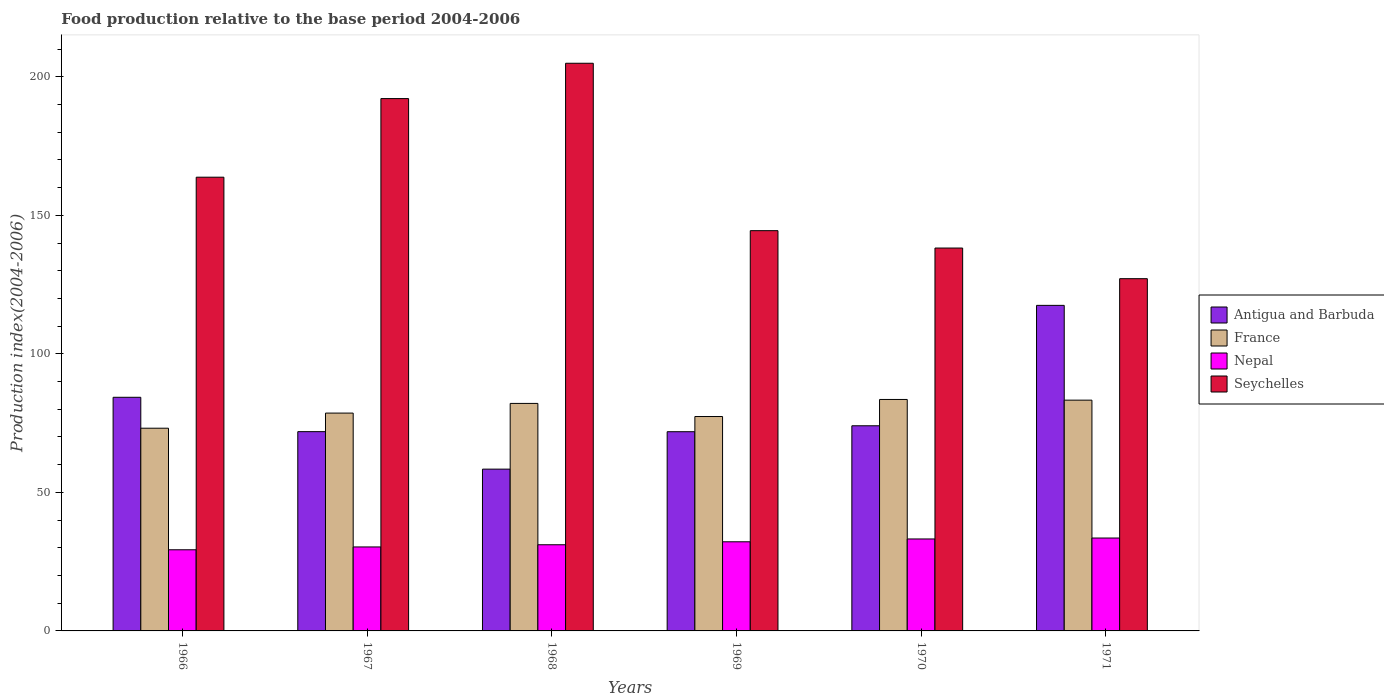How many bars are there on the 4th tick from the left?
Your response must be concise. 4. What is the label of the 5th group of bars from the left?
Your response must be concise. 1970. What is the food production index in France in 1969?
Keep it short and to the point. 77.38. Across all years, what is the maximum food production index in France?
Offer a terse response. 83.54. Across all years, what is the minimum food production index in Antigua and Barbuda?
Provide a short and direct response. 58.39. In which year was the food production index in France minimum?
Provide a short and direct response. 1966. What is the total food production index in France in the graph?
Your answer should be compact. 478.1. What is the difference between the food production index in Seychelles in 1966 and that in 1967?
Provide a succinct answer. -28.37. What is the difference between the food production index in Seychelles in 1971 and the food production index in France in 1967?
Your answer should be compact. 48.51. What is the average food production index in Seychelles per year?
Offer a terse response. 161.76. In the year 1966, what is the difference between the food production index in Nepal and food production index in Antigua and Barbuda?
Ensure brevity in your answer.  -55.03. In how many years, is the food production index in Seychelles greater than 110?
Keep it short and to the point. 6. What is the ratio of the food production index in Antigua and Barbuda in 1970 to that in 1971?
Your answer should be compact. 0.63. What is the difference between the highest and the second highest food production index in Seychelles?
Provide a short and direct response. 12.75. What is the difference between the highest and the lowest food production index in Seychelles?
Provide a succinct answer. 77.75. In how many years, is the food production index in Seychelles greater than the average food production index in Seychelles taken over all years?
Your response must be concise. 3. What does the 3rd bar from the left in 1969 represents?
Make the answer very short. Nepal. What does the 2nd bar from the right in 1969 represents?
Make the answer very short. Nepal. How many bars are there?
Provide a succinct answer. 24. How many years are there in the graph?
Your answer should be very brief. 6. Are the values on the major ticks of Y-axis written in scientific E-notation?
Provide a short and direct response. No. Does the graph contain any zero values?
Offer a very short reply. No. How are the legend labels stacked?
Your answer should be very brief. Vertical. What is the title of the graph?
Offer a terse response. Food production relative to the base period 2004-2006. Does "Lao PDR" appear as one of the legend labels in the graph?
Keep it short and to the point. No. What is the label or title of the Y-axis?
Give a very brief answer. Production index(2004-2006). What is the Production index(2004-2006) of Antigua and Barbuda in 1966?
Make the answer very short. 84.32. What is the Production index(2004-2006) of France in 1966?
Your answer should be compact. 73.16. What is the Production index(2004-2006) of Nepal in 1966?
Your answer should be compact. 29.29. What is the Production index(2004-2006) in Seychelles in 1966?
Make the answer very short. 163.76. What is the Production index(2004-2006) of Antigua and Barbuda in 1967?
Make the answer very short. 71.92. What is the Production index(2004-2006) of France in 1967?
Give a very brief answer. 78.62. What is the Production index(2004-2006) of Nepal in 1967?
Your answer should be very brief. 30.31. What is the Production index(2004-2006) of Seychelles in 1967?
Keep it short and to the point. 192.13. What is the Production index(2004-2006) in Antigua and Barbuda in 1968?
Keep it short and to the point. 58.39. What is the Production index(2004-2006) of France in 1968?
Offer a terse response. 82.11. What is the Production index(2004-2006) of Nepal in 1968?
Make the answer very short. 31.1. What is the Production index(2004-2006) of Seychelles in 1968?
Give a very brief answer. 204.88. What is the Production index(2004-2006) in Antigua and Barbuda in 1969?
Offer a very short reply. 71.9. What is the Production index(2004-2006) in France in 1969?
Provide a short and direct response. 77.38. What is the Production index(2004-2006) of Nepal in 1969?
Your answer should be compact. 32.17. What is the Production index(2004-2006) in Seychelles in 1969?
Ensure brevity in your answer.  144.46. What is the Production index(2004-2006) in Antigua and Barbuda in 1970?
Make the answer very short. 74.04. What is the Production index(2004-2006) of France in 1970?
Offer a very short reply. 83.54. What is the Production index(2004-2006) of Nepal in 1970?
Provide a short and direct response. 33.19. What is the Production index(2004-2006) of Seychelles in 1970?
Your answer should be compact. 138.19. What is the Production index(2004-2006) of Antigua and Barbuda in 1971?
Give a very brief answer. 117.5. What is the Production index(2004-2006) in France in 1971?
Give a very brief answer. 83.29. What is the Production index(2004-2006) of Nepal in 1971?
Ensure brevity in your answer.  33.53. What is the Production index(2004-2006) of Seychelles in 1971?
Offer a very short reply. 127.13. Across all years, what is the maximum Production index(2004-2006) in Antigua and Barbuda?
Make the answer very short. 117.5. Across all years, what is the maximum Production index(2004-2006) in France?
Your answer should be compact. 83.54. Across all years, what is the maximum Production index(2004-2006) of Nepal?
Your response must be concise. 33.53. Across all years, what is the maximum Production index(2004-2006) in Seychelles?
Ensure brevity in your answer.  204.88. Across all years, what is the minimum Production index(2004-2006) in Antigua and Barbuda?
Your answer should be very brief. 58.39. Across all years, what is the minimum Production index(2004-2006) of France?
Your response must be concise. 73.16. Across all years, what is the minimum Production index(2004-2006) in Nepal?
Offer a terse response. 29.29. Across all years, what is the minimum Production index(2004-2006) of Seychelles?
Make the answer very short. 127.13. What is the total Production index(2004-2006) of Antigua and Barbuda in the graph?
Make the answer very short. 478.07. What is the total Production index(2004-2006) of France in the graph?
Your answer should be compact. 478.1. What is the total Production index(2004-2006) of Nepal in the graph?
Provide a succinct answer. 189.59. What is the total Production index(2004-2006) of Seychelles in the graph?
Provide a succinct answer. 970.55. What is the difference between the Production index(2004-2006) of Antigua and Barbuda in 1966 and that in 1967?
Make the answer very short. 12.4. What is the difference between the Production index(2004-2006) in France in 1966 and that in 1967?
Make the answer very short. -5.46. What is the difference between the Production index(2004-2006) of Nepal in 1966 and that in 1967?
Give a very brief answer. -1.02. What is the difference between the Production index(2004-2006) in Seychelles in 1966 and that in 1967?
Provide a short and direct response. -28.37. What is the difference between the Production index(2004-2006) of Antigua and Barbuda in 1966 and that in 1968?
Ensure brevity in your answer.  25.93. What is the difference between the Production index(2004-2006) of France in 1966 and that in 1968?
Keep it short and to the point. -8.95. What is the difference between the Production index(2004-2006) of Nepal in 1966 and that in 1968?
Your response must be concise. -1.81. What is the difference between the Production index(2004-2006) of Seychelles in 1966 and that in 1968?
Provide a succinct answer. -41.12. What is the difference between the Production index(2004-2006) in Antigua and Barbuda in 1966 and that in 1969?
Your answer should be very brief. 12.42. What is the difference between the Production index(2004-2006) of France in 1966 and that in 1969?
Your answer should be very brief. -4.22. What is the difference between the Production index(2004-2006) in Nepal in 1966 and that in 1969?
Offer a terse response. -2.88. What is the difference between the Production index(2004-2006) of Seychelles in 1966 and that in 1969?
Your answer should be very brief. 19.3. What is the difference between the Production index(2004-2006) of Antigua and Barbuda in 1966 and that in 1970?
Ensure brevity in your answer.  10.28. What is the difference between the Production index(2004-2006) of France in 1966 and that in 1970?
Your response must be concise. -10.38. What is the difference between the Production index(2004-2006) in Nepal in 1966 and that in 1970?
Offer a terse response. -3.9. What is the difference between the Production index(2004-2006) in Seychelles in 1966 and that in 1970?
Make the answer very short. 25.57. What is the difference between the Production index(2004-2006) in Antigua and Barbuda in 1966 and that in 1971?
Provide a succinct answer. -33.18. What is the difference between the Production index(2004-2006) in France in 1966 and that in 1971?
Your answer should be very brief. -10.13. What is the difference between the Production index(2004-2006) in Nepal in 1966 and that in 1971?
Your response must be concise. -4.24. What is the difference between the Production index(2004-2006) of Seychelles in 1966 and that in 1971?
Keep it short and to the point. 36.63. What is the difference between the Production index(2004-2006) in Antigua and Barbuda in 1967 and that in 1968?
Your response must be concise. 13.53. What is the difference between the Production index(2004-2006) of France in 1967 and that in 1968?
Your response must be concise. -3.49. What is the difference between the Production index(2004-2006) in Nepal in 1967 and that in 1968?
Ensure brevity in your answer.  -0.79. What is the difference between the Production index(2004-2006) in Seychelles in 1967 and that in 1968?
Provide a succinct answer. -12.75. What is the difference between the Production index(2004-2006) of Antigua and Barbuda in 1967 and that in 1969?
Make the answer very short. 0.02. What is the difference between the Production index(2004-2006) of France in 1967 and that in 1969?
Your response must be concise. 1.24. What is the difference between the Production index(2004-2006) in Nepal in 1967 and that in 1969?
Provide a succinct answer. -1.86. What is the difference between the Production index(2004-2006) of Seychelles in 1967 and that in 1969?
Ensure brevity in your answer.  47.67. What is the difference between the Production index(2004-2006) of Antigua and Barbuda in 1967 and that in 1970?
Offer a terse response. -2.12. What is the difference between the Production index(2004-2006) of France in 1967 and that in 1970?
Your response must be concise. -4.92. What is the difference between the Production index(2004-2006) in Nepal in 1967 and that in 1970?
Keep it short and to the point. -2.88. What is the difference between the Production index(2004-2006) of Seychelles in 1967 and that in 1970?
Provide a succinct answer. 53.94. What is the difference between the Production index(2004-2006) of Antigua and Barbuda in 1967 and that in 1971?
Provide a succinct answer. -45.58. What is the difference between the Production index(2004-2006) of France in 1967 and that in 1971?
Keep it short and to the point. -4.67. What is the difference between the Production index(2004-2006) in Nepal in 1967 and that in 1971?
Provide a short and direct response. -3.22. What is the difference between the Production index(2004-2006) of Seychelles in 1967 and that in 1971?
Offer a terse response. 65. What is the difference between the Production index(2004-2006) in Antigua and Barbuda in 1968 and that in 1969?
Give a very brief answer. -13.51. What is the difference between the Production index(2004-2006) of France in 1968 and that in 1969?
Your answer should be compact. 4.73. What is the difference between the Production index(2004-2006) of Nepal in 1968 and that in 1969?
Ensure brevity in your answer.  -1.07. What is the difference between the Production index(2004-2006) in Seychelles in 1968 and that in 1969?
Provide a succinct answer. 60.42. What is the difference between the Production index(2004-2006) in Antigua and Barbuda in 1968 and that in 1970?
Offer a terse response. -15.65. What is the difference between the Production index(2004-2006) of France in 1968 and that in 1970?
Offer a very short reply. -1.43. What is the difference between the Production index(2004-2006) in Nepal in 1968 and that in 1970?
Ensure brevity in your answer.  -2.09. What is the difference between the Production index(2004-2006) of Seychelles in 1968 and that in 1970?
Ensure brevity in your answer.  66.69. What is the difference between the Production index(2004-2006) of Antigua and Barbuda in 1968 and that in 1971?
Make the answer very short. -59.11. What is the difference between the Production index(2004-2006) of France in 1968 and that in 1971?
Offer a terse response. -1.18. What is the difference between the Production index(2004-2006) in Nepal in 1968 and that in 1971?
Offer a very short reply. -2.43. What is the difference between the Production index(2004-2006) in Seychelles in 1968 and that in 1971?
Give a very brief answer. 77.75. What is the difference between the Production index(2004-2006) of Antigua and Barbuda in 1969 and that in 1970?
Your answer should be very brief. -2.14. What is the difference between the Production index(2004-2006) in France in 1969 and that in 1970?
Keep it short and to the point. -6.16. What is the difference between the Production index(2004-2006) in Nepal in 1969 and that in 1970?
Offer a very short reply. -1.02. What is the difference between the Production index(2004-2006) in Seychelles in 1969 and that in 1970?
Your answer should be compact. 6.27. What is the difference between the Production index(2004-2006) of Antigua and Barbuda in 1969 and that in 1971?
Make the answer very short. -45.6. What is the difference between the Production index(2004-2006) of France in 1969 and that in 1971?
Your answer should be very brief. -5.91. What is the difference between the Production index(2004-2006) in Nepal in 1969 and that in 1971?
Provide a succinct answer. -1.36. What is the difference between the Production index(2004-2006) in Seychelles in 1969 and that in 1971?
Make the answer very short. 17.33. What is the difference between the Production index(2004-2006) of Antigua and Barbuda in 1970 and that in 1971?
Ensure brevity in your answer.  -43.46. What is the difference between the Production index(2004-2006) of France in 1970 and that in 1971?
Provide a short and direct response. 0.25. What is the difference between the Production index(2004-2006) in Nepal in 1970 and that in 1971?
Your answer should be compact. -0.34. What is the difference between the Production index(2004-2006) of Seychelles in 1970 and that in 1971?
Keep it short and to the point. 11.06. What is the difference between the Production index(2004-2006) in Antigua and Barbuda in 1966 and the Production index(2004-2006) in France in 1967?
Ensure brevity in your answer.  5.7. What is the difference between the Production index(2004-2006) of Antigua and Barbuda in 1966 and the Production index(2004-2006) of Nepal in 1967?
Ensure brevity in your answer.  54.01. What is the difference between the Production index(2004-2006) of Antigua and Barbuda in 1966 and the Production index(2004-2006) of Seychelles in 1967?
Offer a very short reply. -107.81. What is the difference between the Production index(2004-2006) in France in 1966 and the Production index(2004-2006) in Nepal in 1967?
Provide a short and direct response. 42.85. What is the difference between the Production index(2004-2006) in France in 1966 and the Production index(2004-2006) in Seychelles in 1967?
Your response must be concise. -118.97. What is the difference between the Production index(2004-2006) of Nepal in 1966 and the Production index(2004-2006) of Seychelles in 1967?
Offer a very short reply. -162.84. What is the difference between the Production index(2004-2006) in Antigua and Barbuda in 1966 and the Production index(2004-2006) in France in 1968?
Ensure brevity in your answer.  2.21. What is the difference between the Production index(2004-2006) in Antigua and Barbuda in 1966 and the Production index(2004-2006) in Nepal in 1968?
Your response must be concise. 53.22. What is the difference between the Production index(2004-2006) of Antigua and Barbuda in 1966 and the Production index(2004-2006) of Seychelles in 1968?
Provide a succinct answer. -120.56. What is the difference between the Production index(2004-2006) of France in 1966 and the Production index(2004-2006) of Nepal in 1968?
Offer a terse response. 42.06. What is the difference between the Production index(2004-2006) of France in 1966 and the Production index(2004-2006) of Seychelles in 1968?
Ensure brevity in your answer.  -131.72. What is the difference between the Production index(2004-2006) in Nepal in 1966 and the Production index(2004-2006) in Seychelles in 1968?
Provide a succinct answer. -175.59. What is the difference between the Production index(2004-2006) of Antigua and Barbuda in 1966 and the Production index(2004-2006) of France in 1969?
Make the answer very short. 6.94. What is the difference between the Production index(2004-2006) in Antigua and Barbuda in 1966 and the Production index(2004-2006) in Nepal in 1969?
Your answer should be compact. 52.15. What is the difference between the Production index(2004-2006) of Antigua and Barbuda in 1966 and the Production index(2004-2006) of Seychelles in 1969?
Provide a short and direct response. -60.14. What is the difference between the Production index(2004-2006) of France in 1966 and the Production index(2004-2006) of Nepal in 1969?
Provide a succinct answer. 40.99. What is the difference between the Production index(2004-2006) in France in 1966 and the Production index(2004-2006) in Seychelles in 1969?
Your answer should be very brief. -71.3. What is the difference between the Production index(2004-2006) in Nepal in 1966 and the Production index(2004-2006) in Seychelles in 1969?
Provide a short and direct response. -115.17. What is the difference between the Production index(2004-2006) of Antigua and Barbuda in 1966 and the Production index(2004-2006) of France in 1970?
Your answer should be very brief. 0.78. What is the difference between the Production index(2004-2006) of Antigua and Barbuda in 1966 and the Production index(2004-2006) of Nepal in 1970?
Your answer should be very brief. 51.13. What is the difference between the Production index(2004-2006) of Antigua and Barbuda in 1966 and the Production index(2004-2006) of Seychelles in 1970?
Provide a short and direct response. -53.87. What is the difference between the Production index(2004-2006) in France in 1966 and the Production index(2004-2006) in Nepal in 1970?
Offer a terse response. 39.97. What is the difference between the Production index(2004-2006) in France in 1966 and the Production index(2004-2006) in Seychelles in 1970?
Your answer should be compact. -65.03. What is the difference between the Production index(2004-2006) of Nepal in 1966 and the Production index(2004-2006) of Seychelles in 1970?
Ensure brevity in your answer.  -108.9. What is the difference between the Production index(2004-2006) of Antigua and Barbuda in 1966 and the Production index(2004-2006) of France in 1971?
Ensure brevity in your answer.  1.03. What is the difference between the Production index(2004-2006) in Antigua and Barbuda in 1966 and the Production index(2004-2006) in Nepal in 1971?
Ensure brevity in your answer.  50.79. What is the difference between the Production index(2004-2006) of Antigua and Barbuda in 1966 and the Production index(2004-2006) of Seychelles in 1971?
Offer a terse response. -42.81. What is the difference between the Production index(2004-2006) in France in 1966 and the Production index(2004-2006) in Nepal in 1971?
Provide a succinct answer. 39.63. What is the difference between the Production index(2004-2006) of France in 1966 and the Production index(2004-2006) of Seychelles in 1971?
Make the answer very short. -53.97. What is the difference between the Production index(2004-2006) of Nepal in 1966 and the Production index(2004-2006) of Seychelles in 1971?
Your answer should be very brief. -97.84. What is the difference between the Production index(2004-2006) in Antigua and Barbuda in 1967 and the Production index(2004-2006) in France in 1968?
Your response must be concise. -10.19. What is the difference between the Production index(2004-2006) of Antigua and Barbuda in 1967 and the Production index(2004-2006) of Nepal in 1968?
Offer a terse response. 40.82. What is the difference between the Production index(2004-2006) of Antigua and Barbuda in 1967 and the Production index(2004-2006) of Seychelles in 1968?
Make the answer very short. -132.96. What is the difference between the Production index(2004-2006) of France in 1967 and the Production index(2004-2006) of Nepal in 1968?
Your response must be concise. 47.52. What is the difference between the Production index(2004-2006) of France in 1967 and the Production index(2004-2006) of Seychelles in 1968?
Keep it short and to the point. -126.26. What is the difference between the Production index(2004-2006) of Nepal in 1967 and the Production index(2004-2006) of Seychelles in 1968?
Ensure brevity in your answer.  -174.57. What is the difference between the Production index(2004-2006) in Antigua and Barbuda in 1967 and the Production index(2004-2006) in France in 1969?
Ensure brevity in your answer.  -5.46. What is the difference between the Production index(2004-2006) in Antigua and Barbuda in 1967 and the Production index(2004-2006) in Nepal in 1969?
Ensure brevity in your answer.  39.75. What is the difference between the Production index(2004-2006) in Antigua and Barbuda in 1967 and the Production index(2004-2006) in Seychelles in 1969?
Provide a succinct answer. -72.54. What is the difference between the Production index(2004-2006) of France in 1967 and the Production index(2004-2006) of Nepal in 1969?
Provide a succinct answer. 46.45. What is the difference between the Production index(2004-2006) in France in 1967 and the Production index(2004-2006) in Seychelles in 1969?
Keep it short and to the point. -65.84. What is the difference between the Production index(2004-2006) in Nepal in 1967 and the Production index(2004-2006) in Seychelles in 1969?
Your answer should be very brief. -114.15. What is the difference between the Production index(2004-2006) of Antigua and Barbuda in 1967 and the Production index(2004-2006) of France in 1970?
Your response must be concise. -11.62. What is the difference between the Production index(2004-2006) in Antigua and Barbuda in 1967 and the Production index(2004-2006) in Nepal in 1970?
Offer a terse response. 38.73. What is the difference between the Production index(2004-2006) of Antigua and Barbuda in 1967 and the Production index(2004-2006) of Seychelles in 1970?
Make the answer very short. -66.27. What is the difference between the Production index(2004-2006) in France in 1967 and the Production index(2004-2006) in Nepal in 1970?
Provide a succinct answer. 45.43. What is the difference between the Production index(2004-2006) of France in 1967 and the Production index(2004-2006) of Seychelles in 1970?
Keep it short and to the point. -59.57. What is the difference between the Production index(2004-2006) in Nepal in 1967 and the Production index(2004-2006) in Seychelles in 1970?
Provide a succinct answer. -107.88. What is the difference between the Production index(2004-2006) in Antigua and Barbuda in 1967 and the Production index(2004-2006) in France in 1971?
Your answer should be very brief. -11.37. What is the difference between the Production index(2004-2006) in Antigua and Barbuda in 1967 and the Production index(2004-2006) in Nepal in 1971?
Your answer should be compact. 38.39. What is the difference between the Production index(2004-2006) in Antigua and Barbuda in 1967 and the Production index(2004-2006) in Seychelles in 1971?
Ensure brevity in your answer.  -55.21. What is the difference between the Production index(2004-2006) of France in 1967 and the Production index(2004-2006) of Nepal in 1971?
Provide a succinct answer. 45.09. What is the difference between the Production index(2004-2006) of France in 1967 and the Production index(2004-2006) of Seychelles in 1971?
Your response must be concise. -48.51. What is the difference between the Production index(2004-2006) of Nepal in 1967 and the Production index(2004-2006) of Seychelles in 1971?
Keep it short and to the point. -96.82. What is the difference between the Production index(2004-2006) in Antigua and Barbuda in 1968 and the Production index(2004-2006) in France in 1969?
Ensure brevity in your answer.  -18.99. What is the difference between the Production index(2004-2006) of Antigua and Barbuda in 1968 and the Production index(2004-2006) of Nepal in 1969?
Provide a short and direct response. 26.22. What is the difference between the Production index(2004-2006) of Antigua and Barbuda in 1968 and the Production index(2004-2006) of Seychelles in 1969?
Offer a very short reply. -86.07. What is the difference between the Production index(2004-2006) in France in 1968 and the Production index(2004-2006) in Nepal in 1969?
Your response must be concise. 49.94. What is the difference between the Production index(2004-2006) in France in 1968 and the Production index(2004-2006) in Seychelles in 1969?
Offer a very short reply. -62.35. What is the difference between the Production index(2004-2006) of Nepal in 1968 and the Production index(2004-2006) of Seychelles in 1969?
Ensure brevity in your answer.  -113.36. What is the difference between the Production index(2004-2006) of Antigua and Barbuda in 1968 and the Production index(2004-2006) of France in 1970?
Your response must be concise. -25.15. What is the difference between the Production index(2004-2006) in Antigua and Barbuda in 1968 and the Production index(2004-2006) in Nepal in 1970?
Keep it short and to the point. 25.2. What is the difference between the Production index(2004-2006) in Antigua and Barbuda in 1968 and the Production index(2004-2006) in Seychelles in 1970?
Your response must be concise. -79.8. What is the difference between the Production index(2004-2006) in France in 1968 and the Production index(2004-2006) in Nepal in 1970?
Ensure brevity in your answer.  48.92. What is the difference between the Production index(2004-2006) of France in 1968 and the Production index(2004-2006) of Seychelles in 1970?
Make the answer very short. -56.08. What is the difference between the Production index(2004-2006) of Nepal in 1968 and the Production index(2004-2006) of Seychelles in 1970?
Provide a short and direct response. -107.09. What is the difference between the Production index(2004-2006) of Antigua and Barbuda in 1968 and the Production index(2004-2006) of France in 1971?
Provide a succinct answer. -24.9. What is the difference between the Production index(2004-2006) of Antigua and Barbuda in 1968 and the Production index(2004-2006) of Nepal in 1971?
Offer a very short reply. 24.86. What is the difference between the Production index(2004-2006) of Antigua and Barbuda in 1968 and the Production index(2004-2006) of Seychelles in 1971?
Make the answer very short. -68.74. What is the difference between the Production index(2004-2006) of France in 1968 and the Production index(2004-2006) of Nepal in 1971?
Make the answer very short. 48.58. What is the difference between the Production index(2004-2006) of France in 1968 and the Production index(2004-2006) of Seychelles in 1971?
Your answer should be compact. -45.02. What is the difference between the Production index(2004-2006) in Nepal in 1968 and the Production index(2004-2006) in Seychelles in 1971?
Offer a terse response. -96.03. What is the difference between the Production index(2004-2006) in Antigua and Barbuda in 1969 and the Production index(2004-2006) in France in 1970?
Ensure brevity in your answer.  -11.64. What is the difference between the Production index(2004-2006) in Antigua and Barbuda in 1969 and the Production index(2004-2006) in Nepal in 1970?
Give a very brief answer. 38.71. What is the difference between the Production index(2004-2006) of Antigua and Barbuda in 1969 and the Production index(2004-2006) of Seychelles in 1970?
Ensure brevity in your answer.  -66.29. What is the difference between the Production index(2004-2006) of France in 1969 and the Production index(2004-2006) of Nepal in 1970?
Make the answer very short. 44.19. What is the difference between the Production index(2004-2006) in France in 1969 and the Production index(2004-2006) in Seychelles in 1970?
Give a very brief answer. -60.81. What is the difference between the Production index(2004-2006) of Nepal in 1969 and the Production index(2004-2006) of Seychelles in 1970?
Offer a terse response. -106.02. What is the difference between the Production index(2004-2006) in Antigua and Barbuda in 1969 and the Production index(2004-2006) in France in 1971?
Offer a terse response. -11.39. What is the difference between the Production index(2004-2006) of Antigua and Barbuda in 1969 and the Production index(2004-2006) of Nepal in 1971?
Ensure brevity in your answer.  38.37. What is the difference between the Production index(2004-2006) of Antigua and Barbuda in 1969 and the Production index(2004-2006) of Seychelles in 1971?
Make the answer very short. -55.23. What is the difference between the Production index(2004-2006) in France in 1969 and the Production index(2004-2006) in Nepal in 1971?
Keep it short and to the point. 43.85. What is the difference between the Production index(2004-2006) of France in 1969 and the Production index(2004-2006) of Seychelles in 1971?
Your response must be concise. -49.75. What is the difference between the Production index(2004-2006) in Nepal in 1969 and the Production index(2004-2006) in Seychelles in 1971?
Give a very brief answer. -94.96. What is the difference between the Production index(2004-2006) of Antigua and Barbuda in 1970 and the Production index(2004-2006) of France in 1971?
Make the answer very short. -9.25. What is the difference between the Production index(2004-2006) in Antigua and Barbuda in 1970 and the Production index(2004-2006) in Nepal in 1971?
Your response must be concise. 40.51. What is the difference between the Production index(2004-2006) of Antigua and Barbuda in 1970 and the Production index(2004-2006) of Seychelles in 1971?
Make the answer very short. -53.09. What is the difference between the Production index(2004-2006) in France in 1970 and the Production index(2004-2006) in Nepal in 1971?
Your answer should be very brief. 50.01. What is the difference between the Production index(2004-2006) of France in 1970 and the Production index(2004-2006) of Seychelles in 1971?
Make the answer very short. -43.59. What is the difference between the Production index(2004-2006) in Nepal in 1970 and the Production index(2004-2006) in Seychelles in 1971?
Ensure brevity in your answer.  -93.94. What is the average Production index(2004-2006) in Antigua and Barbuda per year?
Keep it short and to the point. 79.68. What is the average Production index(2004-2006) in France per year?
Ensure brevity in your answer.  79.68. What is the average Production index(2004-2006) of Nepal per year?
Keep it short and to the point. 31.6. What is the average Production index(2004-2006) of Seychelles per year?
Offer a terse response. 161.76. In the year 1966, what is the difference between the Production index(2004-2006) of Antigua and Barbuda and Production index(2004-2006) of France?
Give a very brief answer. 11.16. In the year 1966, what is the difference between the Production index(2004-2006) of Antigua and Barbuda and Production index(2004-2006) of Nepal?
Keep it short and to the point. 55.03. In the year 1966, what is the difference between the Production index(2004-2006) in Antigua and Barbuda and Production index(2004-2006) in Seychelles?
Your answer should be compact. -79.44. In the year 1966, what is the difference between the Production index(2004-2006) of France and Production index(2004-2006) of Nepal?
Give a very brief answer. 43.87. In the year 1966, what is the difference between the Production index(2004-2006) of France and Production index(2004-2006) of Seychelles?
Keep it short and to the point. -90.6. In the year 1966, what is the difference between the Production index(2004-2006) in Nepal and Production index(2004-2006) in Seychelles?
Provide a succinct answer. -134.47. In the year 1967, what is the difference between the Production index(2004-2006) of Antigua and Barbuda and Production index(2004-2006) of Nepal?
Ensure brevity in your answer.  41.61. In the year 1967, what is the difference between the Production index(2004-2006) of Antigua and Barbuda and Production index(2004-2006) of Seychelles?
Provide a short and direct response. -120.21. In the year 1967, what is the difference between the Production index(2004-2006) of France and Production index(2004-2006) of Nepal?
Your answer should be very brief. 48.31. In the year 1967, what is the difference between the Production index(2004-2006) in France and Production index(2004-2006) in Seychelles?
Provide a short and direct response. -113.51. In the year 1967, what is the difference between the Production index(2004-2006) of Nepal and Production index(2004-2006) of Seychelles?
Provide a succinct answer. -161.82. In the year 1968, what is the difference between the Production index(2004-2006) of Antigua and Barbuda and Production index(2004-2006) of France?
Give a very brief answer. -23.72. In the year 1968, what is the difference between the Production index(2004-2006) of Antigua and Barbuda and Production index(2004-2006) of Nepal?
Keep it short and to the point. 27.29. In the year 1968, what is the difference between the Production index(2004-2006) in Antigua and Barbuda and Production index(2004-2006) in Seychelles?
Make the answer very short. -146.49. In the year 1968, what is the difference between the Production index(2004-2006) in France and Production index(2004-2006) in Nepal?
Make the answer very short. 51.01. In the year 1968, what is the difference between the Production index(2004-2006) of France and Production index(2004-2006) of Seychelles?
Keep it short and to the point. -122.77. In the year 1968, what is the difference between the Production index(2004-2006) of Nepal and Production index(2004-2006) of Seychelles?
Ensure brevity in your answer.  -173.78. In the year 1969, what is the difference between the Production index(2004-2006) in Antigua and Barbuda and Production index(2004-2006) in France?
Keep it short and to the point. -5.48. In the year 1969, what is the difference between the Production index(2004-2006) in Antigua and Barbuda and Production index(2004-2006) in Nepal?
Give a very brief answer. 39.73. In the year 1969, what is the difference between the Production index(2004-2006) of Antigua and Barbuda and Production index(2004-2006) of Seychelles?
Keep it short and to the point. -72.56. In the year 1969, what is the difference between the Production index(2004-2006) of France and Production index(2004-2006) of Nepal?
Your answer should be compact. 45.21. In the year 1969, what is the difference between the Production index(2004-2006) of France and Production index(2004-2006) of Seychelles?
Keep it short and to the point. -67.08. In the year 1969, what is the difference between the Production index(2004-2006) in Nepal and Production index(2004-2006) in Seychelles?
Make the answer very short. -112.29. In the year 1970, what is the difference between the Production index(2004-2006) of Antigua and Barbuda and Production index(2004-2006) of France?
Provide a succinct answer. -9.5. In the year 1970, what is the difference between the Production index(2004-2006) of Antigua and Barbuda and Production index(2004-2006) of Nepal?
Keep it short and to the point. 40.85. In the year 1970, what is the difference between the Production index(2004-2006) of Antigua and Barbuda and Production index(2004-2006) of Seychelles?
Give a very brief answer. -64.15. In the year 1970, what is the difference between the Production index(2004-2006) of France and Production index(2004-2006) of Nepal?
Ensure brevity in your answer.  50.35. In the year 1970, what is the difference between the Production index(2004-2006) in France and Production index(2004-2006) in Seychelles?
Provide a succinct answer. -54.65. In the year 1970, what is the difference between the Production index(2004-2006) of Nepal and Production index(2004-2006) of Seychelles?
Keep it short and to the point. -105. In the year 1971, what is the difference between the Production index(2004-2006) of Antigua and Barbuda and Production index(2004-2006) of France?
Give a very brief answer. 34.21. In the year 1971, what is the difference between the Production index(2004-2006) of Antigua and Barbuda and Production index(2004-2006) of Nepal?
Ensure brevity in your answer.  83.97. In the year 1971, what is the difference between the Production index(2004-2006) of Antigua and Barbuda and Production index(2004-2006) of Seychelles?
Your answer should be compact. -9.63. In the year 1971, what is the difference between the Production index(2004-2006) of France and Production index(2004-2006) of Nepal?
Provide a succinct answer. 49.76. In the year 1971, what is the difference between the Production index(2004-2006) in France and Production index(2004-2006) in Seychelles?
Offer a terse response. -43.84. In the year 1971, what is the difference between the Production index(2004-2006) of Nepal and Production index(2004-2006) of Seychelles?
Give a very brief answer. -93.6. What is the ratio of the Production index(2004-2006) in Antigua and Barbuda in 1966 to that in 1967?
Keep it short and to the point. 1.17. What is the ratio of the Production index(2004-2006) of France in 1966 to that in 1967?
Ensure brevity in your answer.  0.93. What is the ratio of the Production index(2004-2006) of Nepal in 1966 to that in 1967?
Keep it short and to the point. 0.97. What is the ratio of the Production index(2004-2006) of Seychelles in 1966 to that in 1967?
Your response must be concise. 0.85. What is the ratio of the Production index(2004-2006) of Antigua and Barbuda in 1966 to that in 1968?
Offer a terse response. 1.44. What is the ratio of the Production index(2004-2006) in France in 1966 to that in 1968?
Make the answer very short. 0.89. What is the ratio of the Production index(2004-2006) of Nepal in 1966 to that in 1968?
Provide a short and direct response. 0.94. What is the ratio of the Production index(2004-2006) in Seychelles in 1966 to that in 1968?
Offer a very short reply. 0.8. What is the ratio of the Production index(2004-2006) in Antigua and Barbuda in 1966 to that in 1969?
Provide a short and direct response. 1.17. What is the ratio of the Production index(2004-2006) in France in 1966 to that in 1969?
Ensure brevity in your answer.  0.95. What is the ratio of the Production index(2004-2006) of Nepal in 1966 to that in 1969?
Your answer should be very brief. 0.91. What is the ratio of the Production index(2004-2006) in Seychelles in 1966 to that in 1969?
Make the answer very short. 1.13. What is the ratio of the Production index(2004-2006) of Antigua and Barbuda in 1966 to that in 1970?
Provide a succinct answer. 1.14. What is the ratio of the Production index(2004-2006) of France in 1966 to that in 1970?
Your answer should be very brief. 0.88. What is the ratio of the Production index(2004-2006) of Nepal in 1966 to that in 1970?
Provide a succinct answer. 0.88. What is the ratio of the Production index(2004-2006) in Seychelles in 1966 to that in 1970?
Ensure brevity in your answer.  1.19. What is the ratio of the Production index(2004-2006) of Antigua and Barbuda in 1966 to that in 1971?
Your response must be concise. 0.72. What is the ratio of the Production index(2004-2006) in France in 1966 to that in 1971?
Provide a succinct answer. 0.88. What is the ratio of the Production index(2004-2006) of Nepal in 1966 to that in 1971?
Make the answer very short. 0.87. What is the ratio of the Production index(2004-2006) in Seychelles in 1966 to that in 1971?
Provide a succinct answer. 1.29. What is the ratio of the Production index(2004-2006) in Antigua and Barbuda in 1967 to that in 1968?
Offer a very short reply. 1.23. What is the ratio of the Production index(2004-2006) in France in 1967 to that in 1968?
Make the answer very short. 0.96. What is the ratio of the Production index(2004-2006) in Nepal in 1967 to that in 1968?
Ensure brevity in your answer.  0.97. What is the ratio of the Production index(2004-2006) of Seychelles in 1967 to that in 1968?
Your response must be concise. 0.94. What is the ratio of the Production index(2004-2006) of Antigua and Barbuda in 1967 to that in 1969?
Your response must be concise. 1. What is the ratio of the Production index(2004-2006) of France in 1967 to that in 1969?
Your answer should be compact. 1.02. What is the ratio of the Production index(2004-2006) in Nepal in 1967 to that in 1969?
Ensure brevity in your answer.  0.94. What is the ratio of the Production index(2004-2006) in Seychelles in 1967 to that in 1969?
Offer a very short reply. 1.33. What is the ratio of the Production index(2004-2006) of Antigua and Barbuda in 1967 to that in 1970?
Ensure brevity in your answer.  0.97. What is the ratio of the Production index(2004-2006) in France in 1967 to that in 1970?
Keep it short and to the point. 0.94. What is the ratio of the Production index(2004-2006) in Nepal in 1967 to that in 1970?
Provide a succinct answer. 0.91. What is the ratio of the Production index(2004-2006) in Seychelles in 1967 to that in 1970?
Provide a short and direct response. 1.39. What is the ratio of the Production index(2004-2006) in Antigua and Barbuda in 1967 to that in 1971?
Your response must be concise. 0.61. What is the ratio of the Production index(2004-2006) in France in 1967 to that in 1971?
Your answer should be compact. 0.94. What is the ratio of the Production index(2004-2006) of Nepal in 1967 to that in 1971?
Your answer should be very brief. 0.9. What is the ratio of the Production index(2004-2006) of Seychelles in 1967 to that in 1971?
Keep it short and to the point. 1.51. What is the ratio of the Production index(2004-2006) in Antigua and Barbuda in 1968 to that in 1969?
Keep it short and to the point. 0.81. What is the ratio of the Production index(2004-2006) in France in 1968 to that in 1969?
Offer a very short reply. 1.06. What is the ratio of the Production index(2004-2006) in Nepal in 1968 to that in 1969?
Give a very brief answer. 0.97. What is the ratio of the Production index(2004-2006) in Seychelles in 1968 to that in 1969?
Your answer should be compact. 1.42. What is the ratio of the Production index(2004-2006) of Antigua and Barbuda in 1968 to that in 1970?
Keep it short and to the point. 0.79. What is the ratio of the Production index(2004-2006) of France in 1968 to that in 1970?
Keep it short and to the point. 0.98. What is the ratio of the Production index(2004-2006) in Nepal in 1968 to that in 1970?
Make the answer very short. 0.94. What is the ratio of the Production index(2004-2006) in Seychelles in 1968 to that in 1970?
Your response must be concise. 1.48. What is the ratio of the Production index(2004-2006) in Antigua and Barbuda in 1968 to that in 1971?
Your answer should be compact. 0.5. What is the ratio of the Production index(2004-2006) in France in 1968 to that in 1971?
Offer a terse response. 0.99. What is the ratio of the Production index(2004-2006) of Nepal in 1968 to that in 1971?
Offer a terse response. 0.93. What is the ratio of the Production index(2004-2006) of Seychelles in 1968 to that in 1971?
Your answer should be very brief. 1.61. What is the ratio of the Production index(2004-2006) in Antigua and Barbuda in 1969 to that in 1970?
Make the answer very short. 0.97. What is the ratio of the Production index(2004-2006) of France in 1969 to that in 1970?
Make the answer very short. 0.93. What is the ratio of the Production index(2004-2006) in Nepal in 1969 to that in 1970?
Your answer should be very brief. 0.97. What is the ratio of the Production index(2004-2006) in Seychelles in 1969 to that in 1970?
Provide a short and direct response. 1.05. What is the ratio of the Production index(2004-2006) of Antigua and Barbuda in 1969 to that in 1971?
Make the answer very short. 0.61. What is the ratio of the Production index(2004-2006) in France in 1969 to that in 1971?
Keep it short and to the point. 0.93. What is the ratio of the Production index(2004-2006) in Nepal in 1969 to that in 1971?
Ensure brevity in your answer.  0.96. What is the ratio of the Production index(2004-2006) of Seychelles in 1969 to that in 1971?
Provide a succinct answer. 1.14. What is the ratio of the Production index(2004-2006) in Antigua and Barbuda in 1970 to that in 1971?
Provide a succinct answer. 0.63. What is the ratio of the Production index(2004-2006) in Seychelles in 1970 to that in 1971?
Give a very brief answer. 1.09. What is the difference between the highest and the second highest Production index(2004-2006) in Antigua and Barbuda?
Keep it short and to the point. 33.18. What is the difference between the highest and the second highest Production index(2004-2006) in Nepal?
Provide a succinct answer. 0.34. What is the difference between the highest and the second highest Production index(2004-2006) in Seychelles?
Give a very brief answer. 12.75. What is the difference between the highest and the lowest Production index(2004-2006) of Antigua and Barbuda?
Keep it short and to the point. 59.11. What is the difference between the highest and the lowest Production index(2004-2006) of France?
Ensure brevity in your answer.  10.38. What is the difference between the highest and the lowest Production index(2004-2006) in Nepal?
Ensure brevity in your answer.  4.24. What is the difference between the highest and the lowest Production index(2004-2006) of Seychelles?
Offer a terse response. 77.75. 